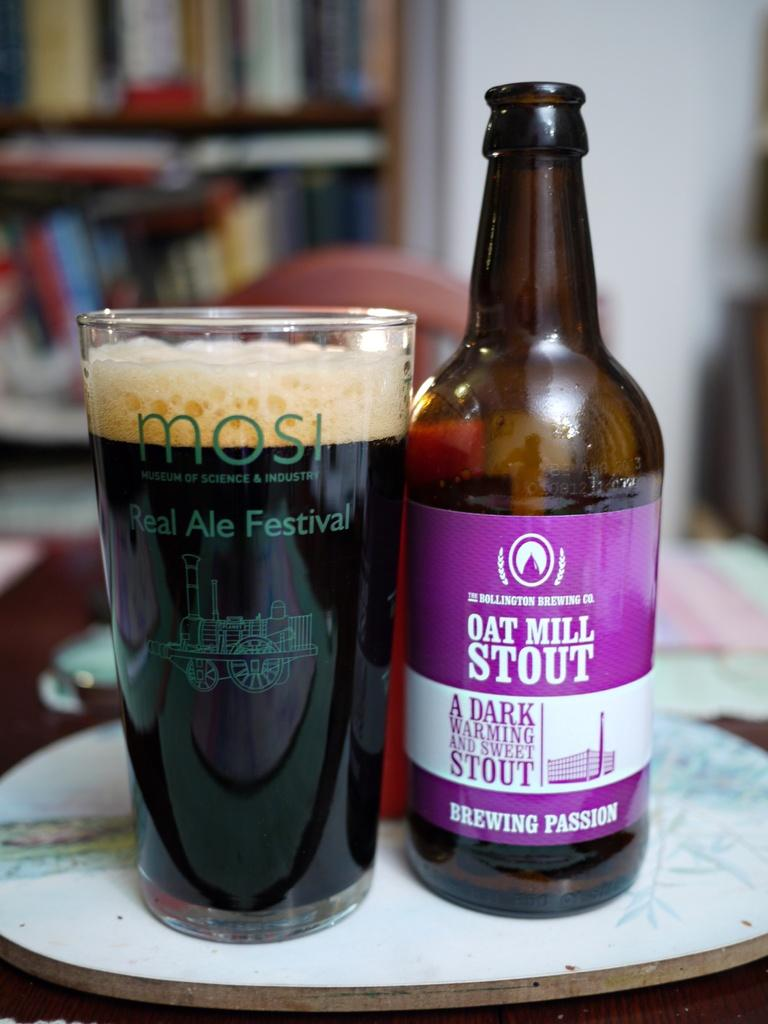Provide a one-sentence caption for the provided image. a bottle of oat mill stout a dark warming and sweet stout next to a glass filled of it. 